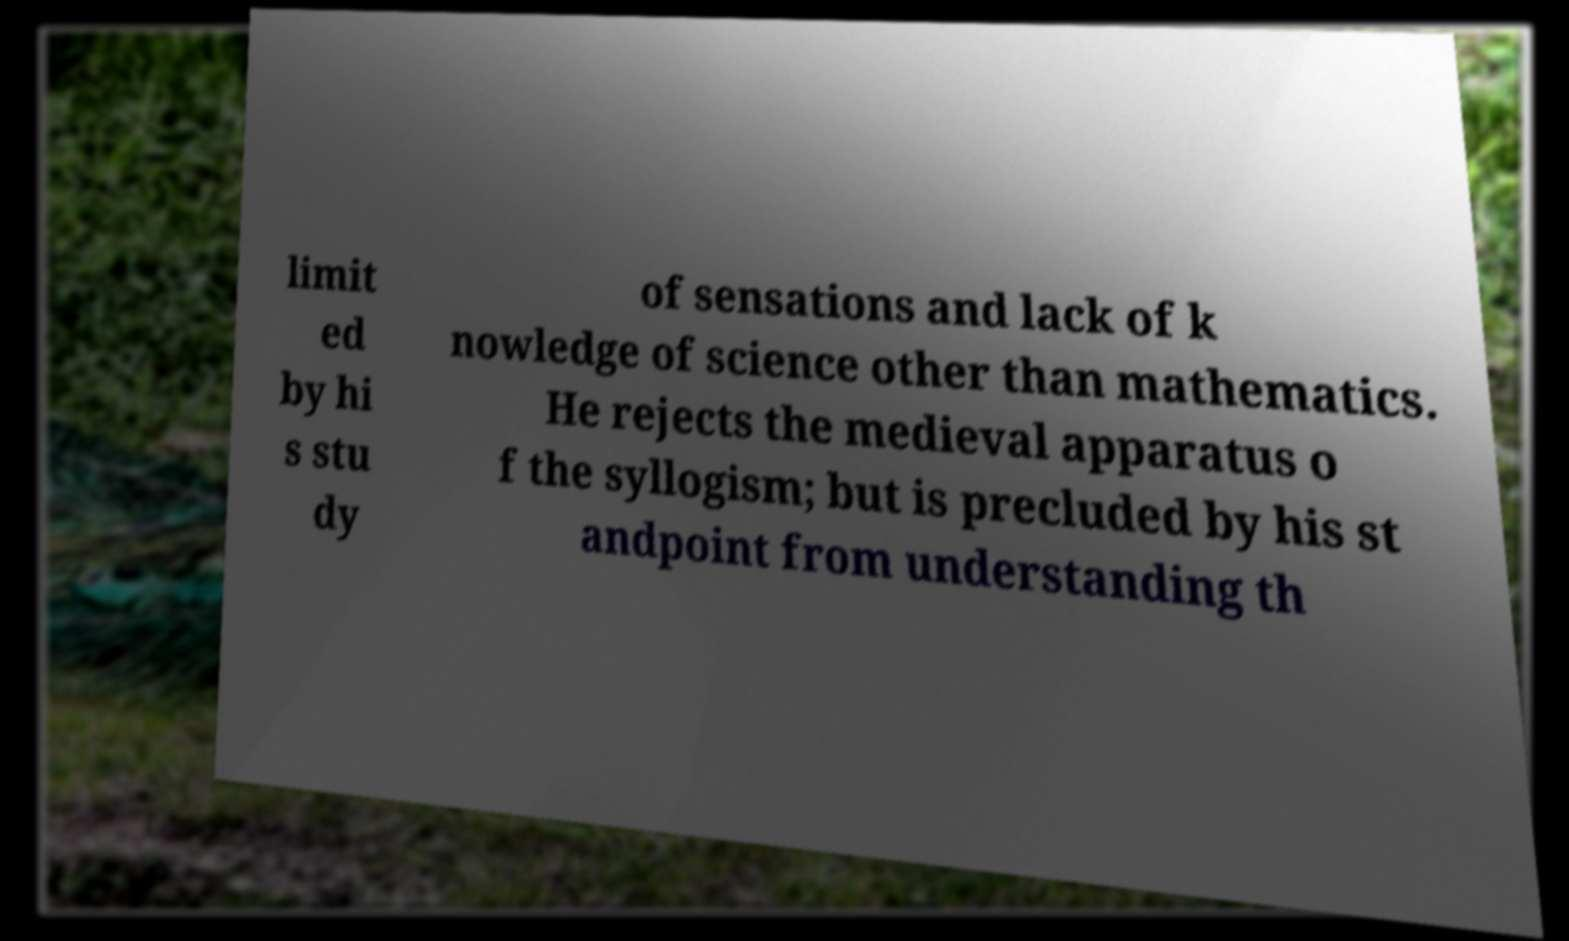I need the written content from this picture converted into text. Can you do that? limit ed by hi s stu dy of sensations and lack of k nowledge of science other than mathematics. He rejects the medieval apparatus o f the syllogism; but is precluded by his st andpoint from understanding th 